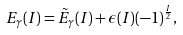Convert formula to latex. <formula><loc_0><loc_0><loc_500><loc_500>E _ { \gamma } ( I ) = \tilde { E } _ { \gamma } ( I ) + \epsilon ( I ) ( - 1 ) ^ { \frac { I } { 2 } } ,</formula> 